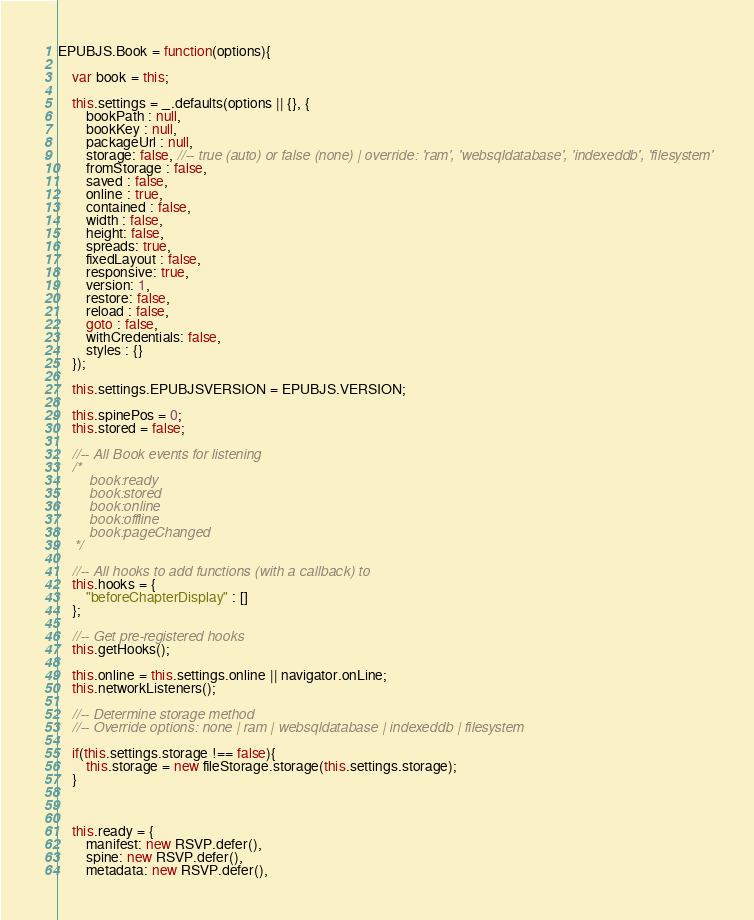Convert code to text. <code><loc_0><loc_0><loc_500><loc_500><_JavaScript_>EPUBJS.Book = function(options){

	var book = this;
	
	this.settings = _.defaults(options || {}, {
		bookPath : null,
		bookKey : null,
		packageUrl : null,
		storage: false, //-- true (auto) or false (none) | override: 'ram', 'websqldatabase', 'indexeddb', 'filesystem'
		fromStorage : false,
		saved : false,
		online : true,
		contained : false,
		width : false,
		height: false,
		spreads: true,
		fixedLayout : false,
		responsive: true,
		version: 1,
		restore: false,
		reload : false,
		goto : false,
		withCredentials: false,
		styles : {}
	});
	
	this.settings.EPUBJSVERSION = EPUBJS.VERSION;
	
	this.spinePos = 0;
	this.stored = false;

	//-- All Book events for listening
	/*
		book:ready
		book:stored
		book:online
		book:offline
		book:pageChanged
	*/
	
	//-- All hooks to add functions (with a callback) to 
	this.hooks = {
		"beforeChapterDisplay" : []
	};
	
	//-- Get pre-registered hooks
	this.getHooks();
			
	this.online = this.settings.online || navigator.onLine;
	this.networkListeners();
		
	//-- Determine storage method
	//-- Override options: none | ram | websqldatabase | indexeddb | filesystem
	
	if(this.settings.storage !== false){
		this.storage = new fileStorage.storage(this.settings.storage);
	}
	
	
	
	this.ready = {
		manifest: new RSVP.defer(),
		spine: new RSVP.defer(),
		metadata: new RSVP.defer(),</code> 